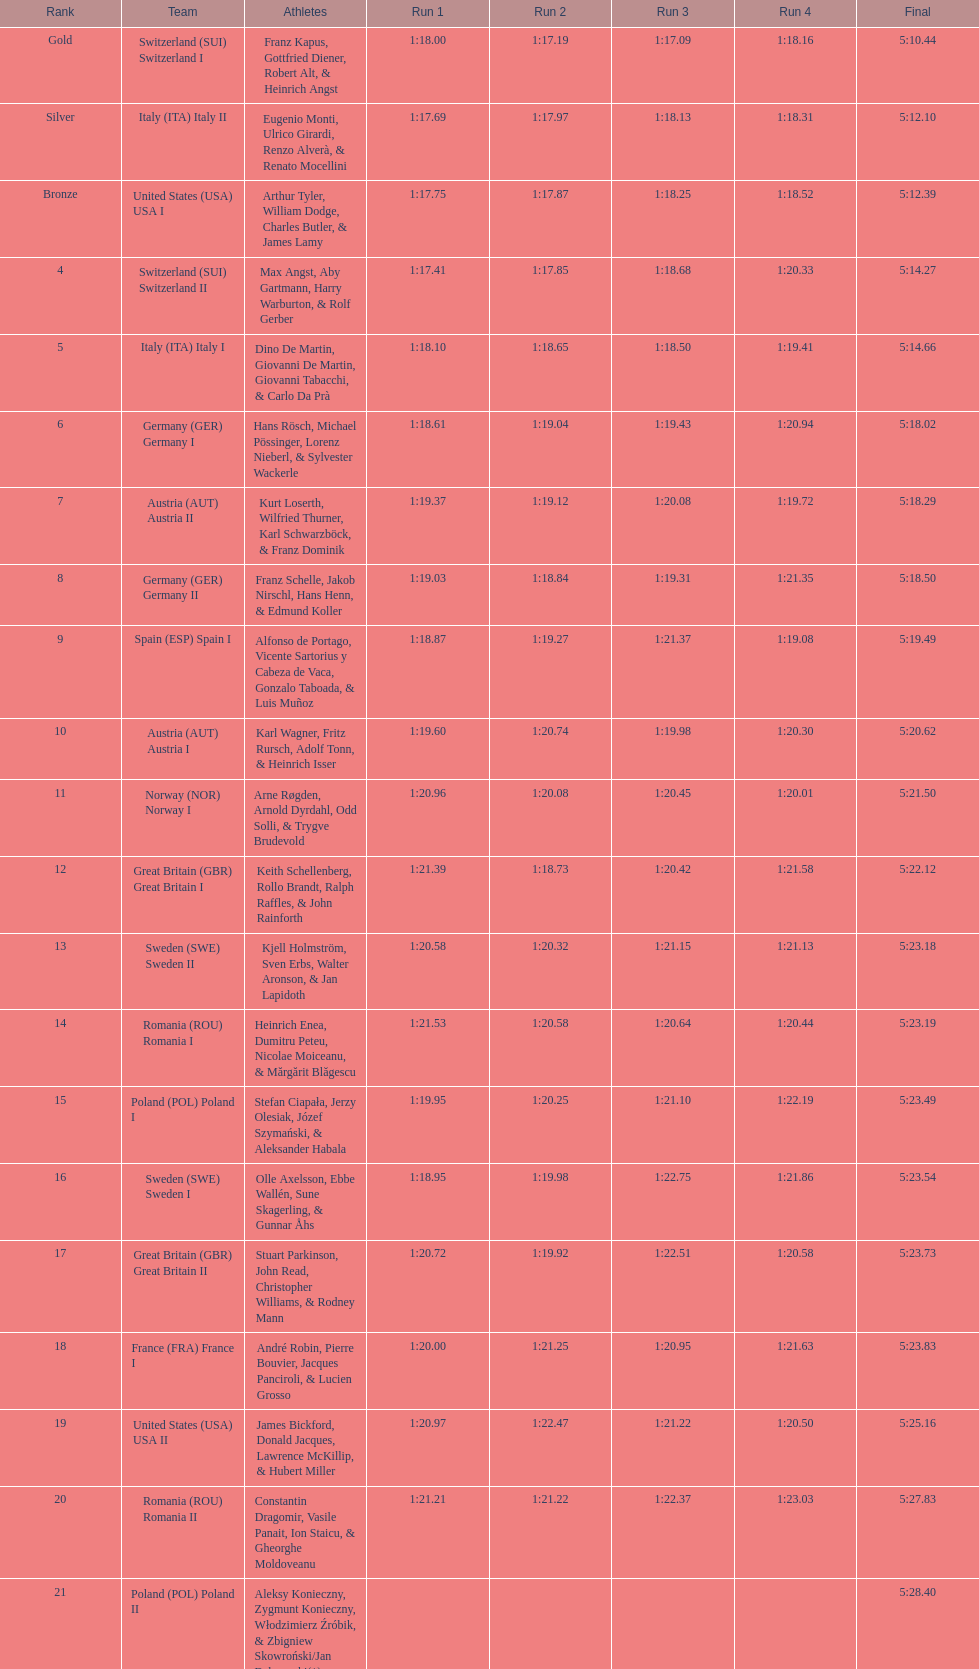What team comes after italy (ita) italy i? Germany I. 